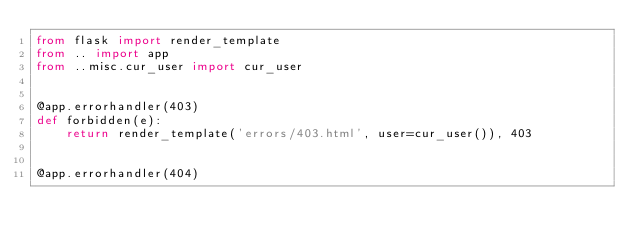<code> <loc_0><loc_0><loc_500><loc_500><_Python_>from flask import render_template
from .. import app
from ..misc.cur_user import cur_user


@app.errorhandler(403)
def forbidden(e):
    return render_template('errors/403.html', user=cur_user()), 403


@app.errorhandler(404)</code> 